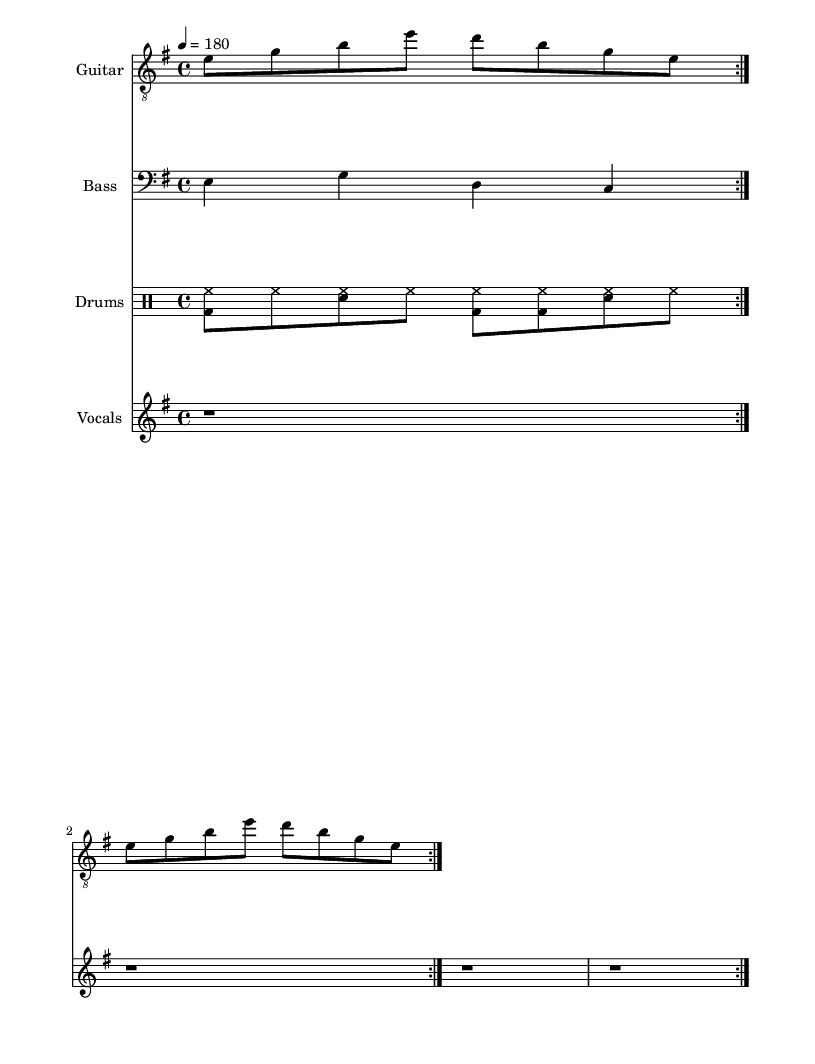What is the key signature of this music? The key signature is E minor, which has one sharp (F#). This is indicated by the presence of the sharp sign on the F line in the key signature at the beginning of the score.
Answer: E minor What is the time signature of this music? The time signature is 4/4, which indicates that there are four beats in each measure and the quarter note gets one beat. This is clearly stated at the beginning of the score.
Answer: 4/4 What is the tempo marking for this piece? The tempo marking is quarter note equals 180, which sets the speed of the music. This is specified in the tempo instruction provided in the global section of the score.
Answer: 180 How many measures are in the repeating section of the guitar part? The guitar part contains a repeating section that lasts for four measures since the riff is repeated twice, and each repetition is comprised of two measures.
Answer: 4 What do the lyrics critique in this song? The lyrics critique corporate greed and consumerism, highlighting the struggles of being trapped in a cycle of buying and selling, as stated in the first line of the lyrics.
Answer: Corporate greed What type of musical style does this piece represent? This piece represents hardcore punk music, characterized by its quick tempo, straightforward structure, and lyrics that express dissent against consumerism and capitalism. This is inferred from the terms like "hardcore punk" and the content of the lyrics.
Answer: Hardcore punk What is the role of the drums in this piece? The drums serve to maintain a fast-paced, driving rhythm that supports the aggressive nature of the music, which is typical in punk. The drum pattern displayed contributes to this role by providing a backbone to the song.
Answer: Driving rhythm 